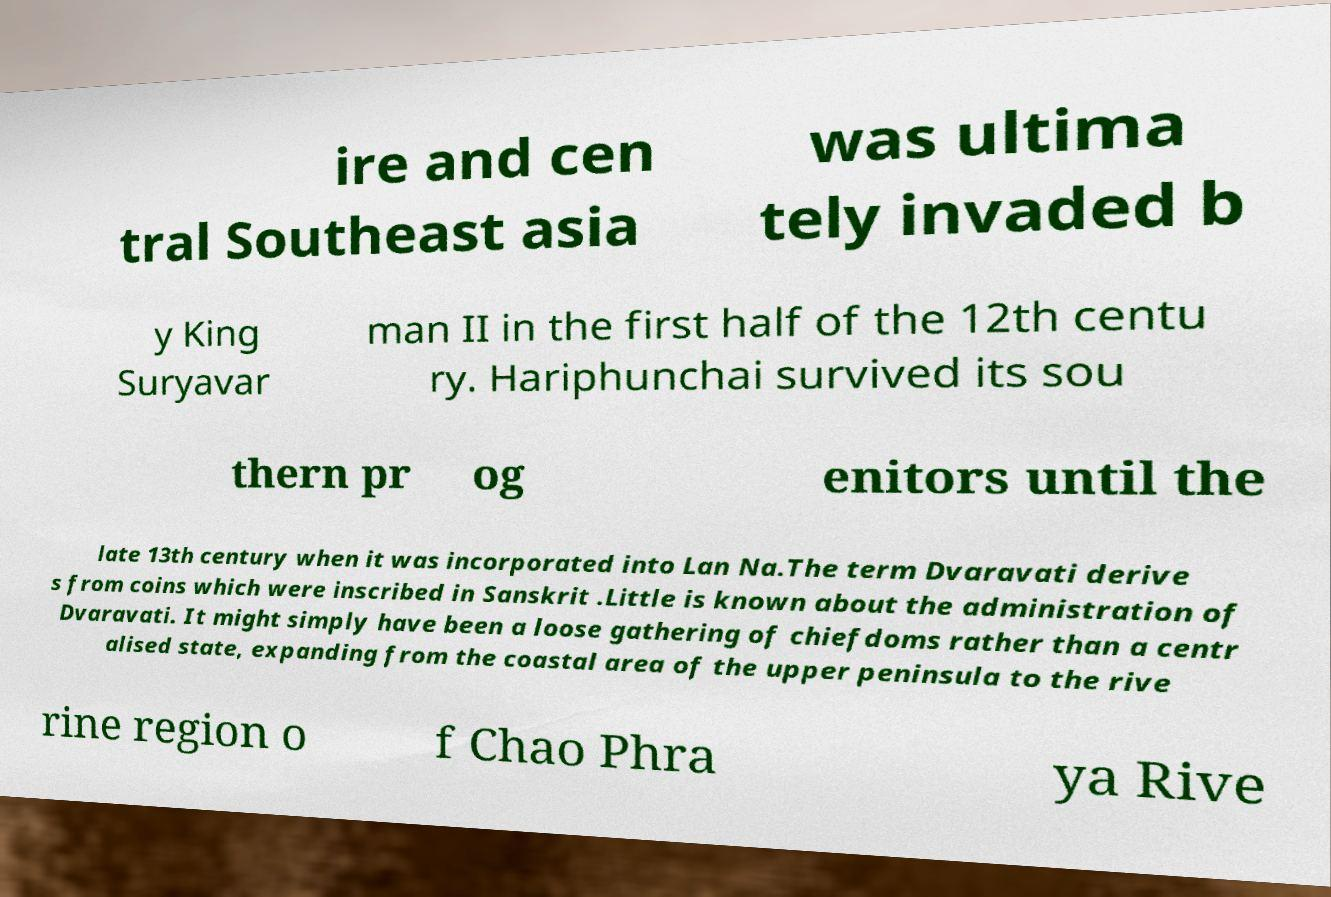Please identify and transcribe the text found in this image. ire and cen tral Southeast asia was ultima tely invaded b y King Suryavar man II in the first half of the 12th centu ry. Hariphunchai survived its sou thern pr og enitors until the late 13th century when it was incorporated into Lan Na.The term Dvaravati derive s from coins which were inscribed in Sanskrit .Little is known about the administration of Dvaravati. It might simply have been a loose gathering of chiefdoms rather than a centr alised state, expanding from the coastal area of the upper peninsula to the rive rine region o f Chao Phra ya Rive 